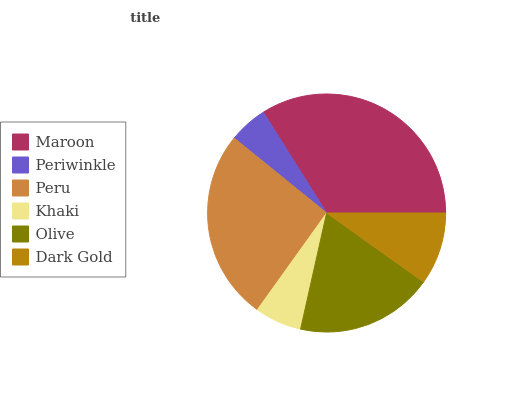Is Periwinkle the minimum?
Answer yes or no. Yes. Is Maroon the maximum?
Answer yes or no. Yes. Is Peru the minimum?
Answer yes or no. No. Is Peru the maximum?
Answer yes or no. No. Is Peru greater than Periwinkle?
Answer yes or no. Yes. Is Periwinkle less than Peru?
Answer yes or no. Yes. Is Periwinkle greater than Peru?
Answer yes or no. No. Is Peru less than Periwinkle?
Answer yes or no. No. Is Olive the high median?
Answer yes or no. Yes. Is Dark Gold the low median?
Answer yes or no. Yes. Is Khaki the high median?
Answer yes or no. No. Is Maroon the low median?
Answer yes or no. No. 